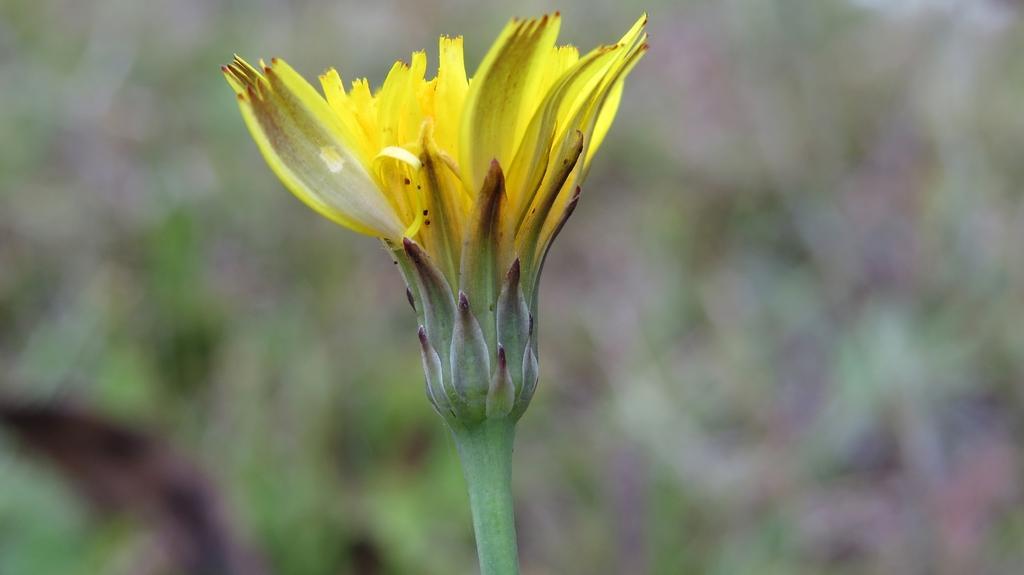Please provide a concise description of this image. In the center of the image we can see a flower. 